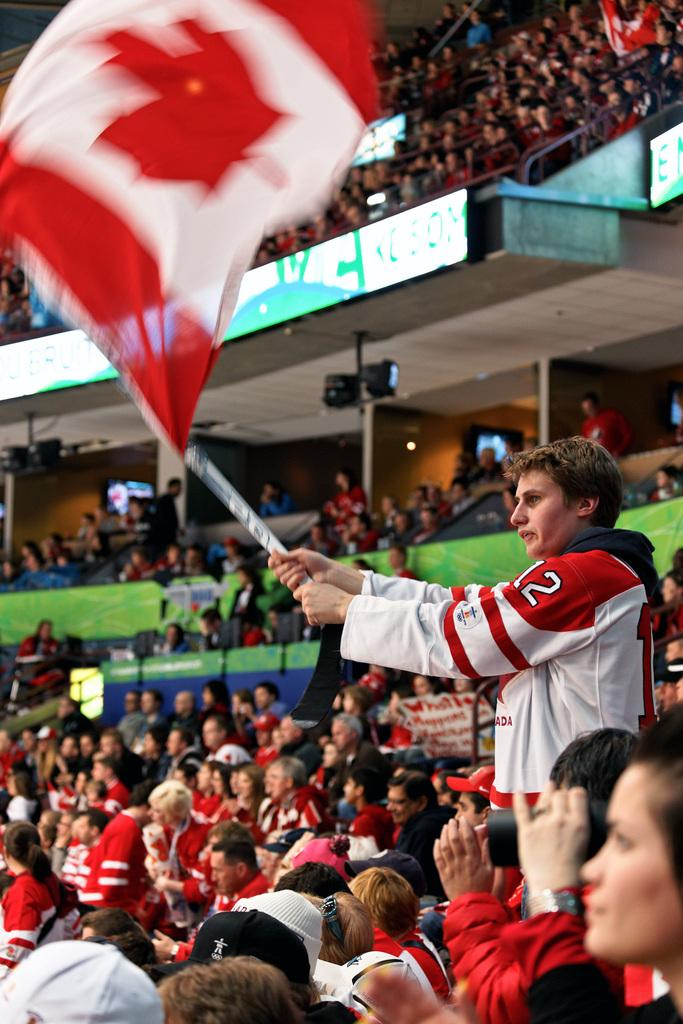How many people are present in the image? There are many people in the image. Where are the people located in the image? The people are seated in an audience area. What are the people doing in the image? The people are watching something. Can you describe the boy in the image? There is a boy standing in the image, and he is holding a flag. What type of lunchroom is visible in the image? There is no lunchroom present in the image. What is the reason for the war depicted in the image? There is no war depicted in the image; it features an audience watching something. 